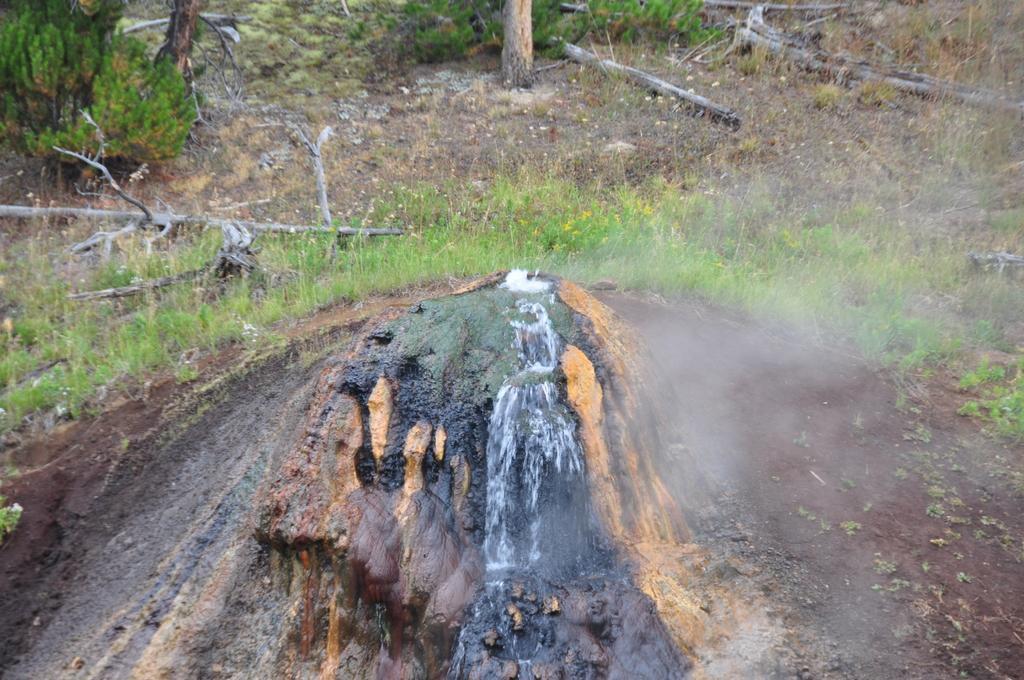Could you give a brief overview of what you see in this image? In the center of the image there is rock. In the background of the image there are tree trunks. There is grass. 